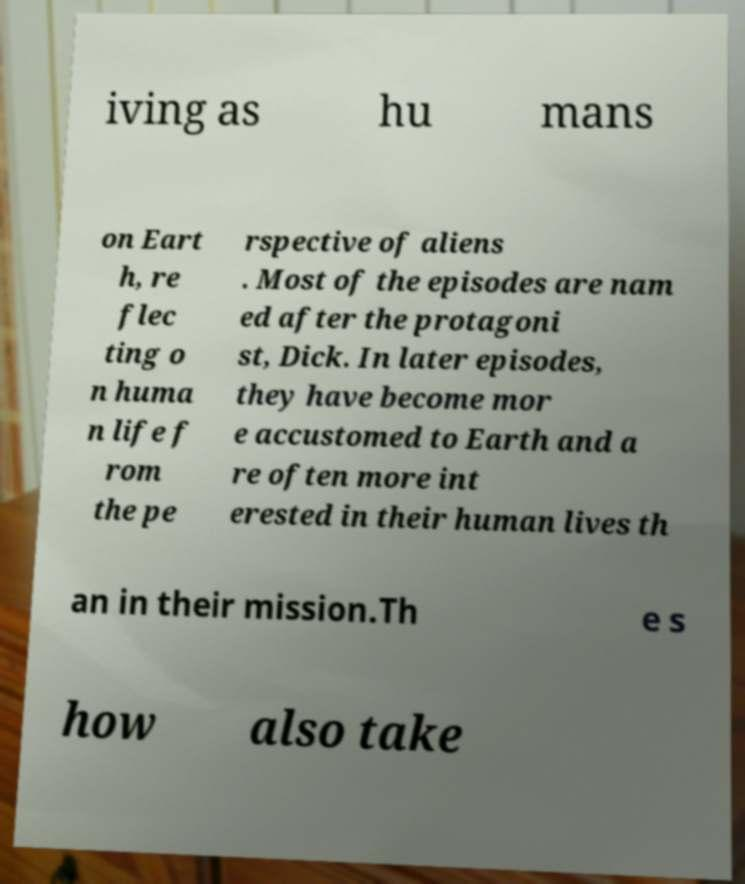Can you accurately transcribe the text from the provided image for me? iving as hu mans on Eart h, re flec ting o n huma n life f rom the pe rspective of aliens . Most of the episodes are nam ed after the protagoni st, Dick. In later episodes, they have become mor e accustomed to Earth and a re often more int erested in their human lives th an in their mission.Th e s how also take 